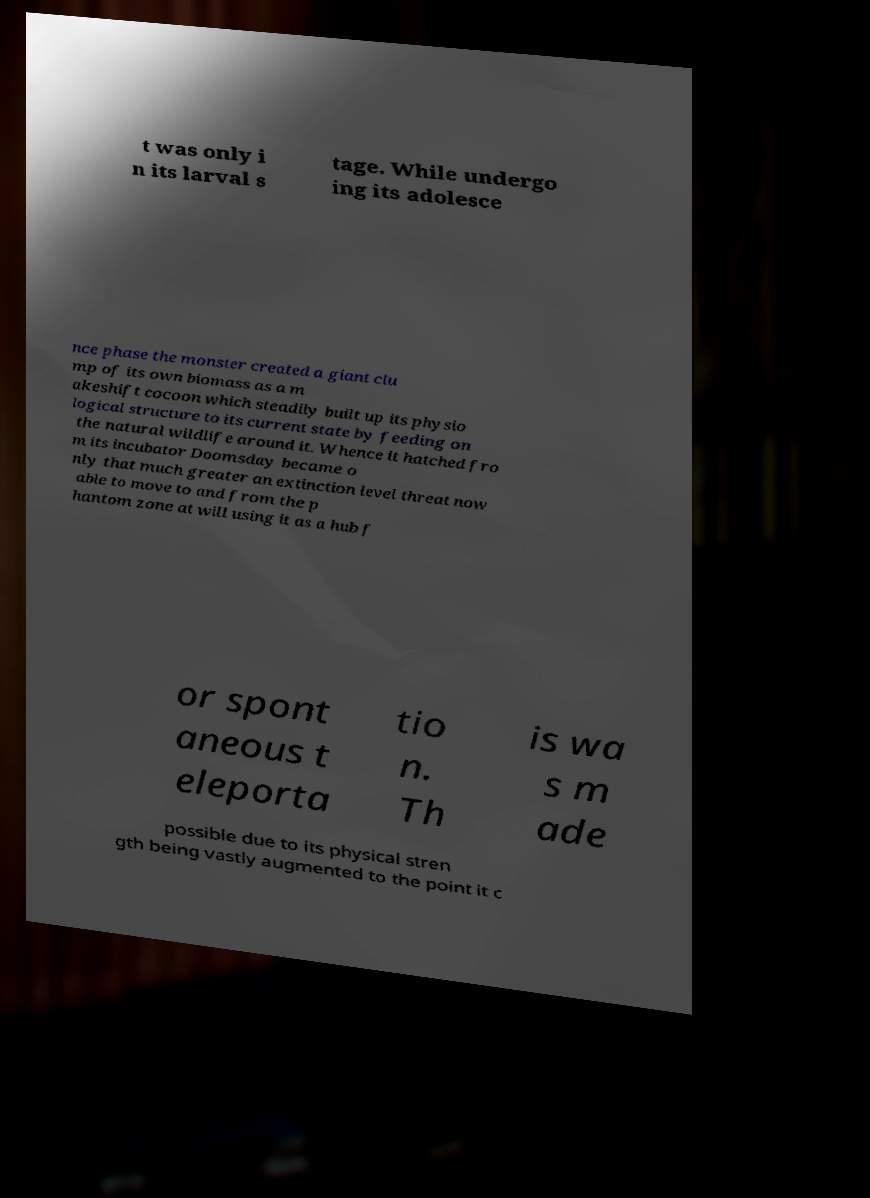Could you extract and type out the text from this image? t was only i n its larval s tage. While undergo ing its adolesce nce phase the monster created a giant clu mp of its own biomass as a m akeshift cocoon which steadily built up its physio logical structure to its current state by feeding on the natural wildlife around it. Whence it hatched fro m its incubator Doomsday became o nly that much greater an extinction level threat now able to move to and from the p hantom zone at will using it as a hub f or spont aneous t eleporta tio n. Th is wa s m ade possible due to its physical stren gth being vastly augmented to the point it c 